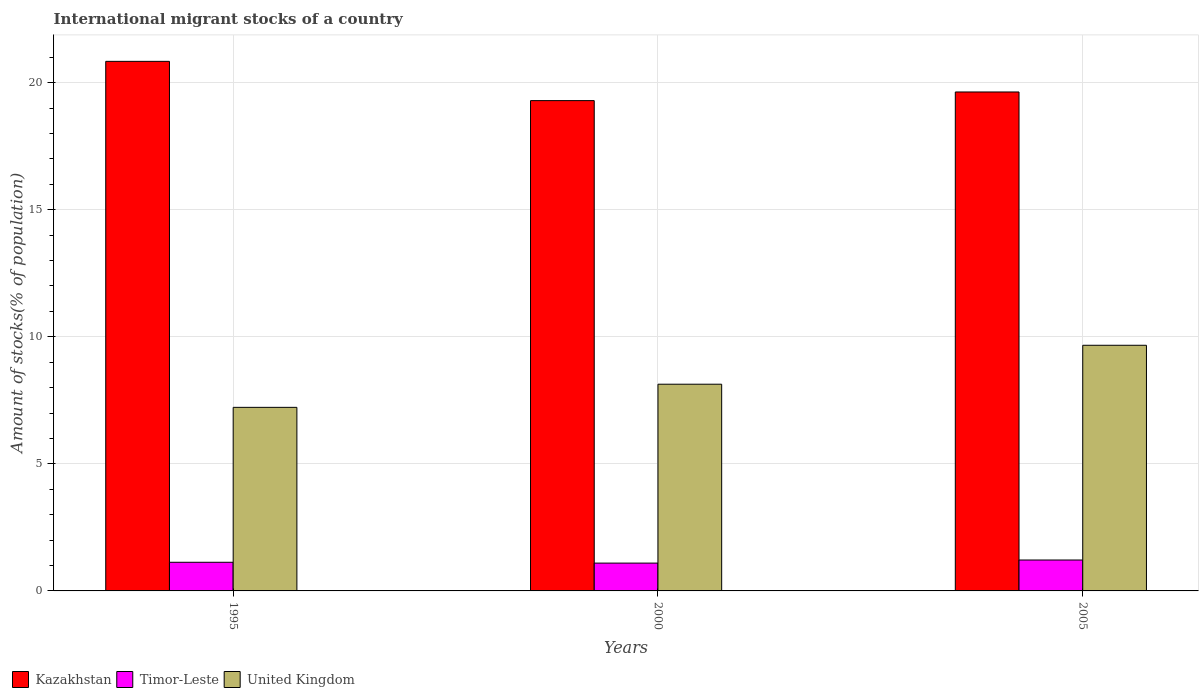How many groups of bars are there?
Ensure brevity in your answer.  3. Are the number of bars on each tick of the X-axis equal?
Your response must be concise. Yes. How many bars are there on the 3rd tick from the left?
Make the answer very short. 3. How many bars are there on the 1st tick from the right?
Keep it short and to the point. 3. What is the amount of stocks in in Timor-Leste in 2005?
Keep it short and to the point. 1.22. Across all years, what is the maximum amount of stocks in in Timor-Leste?
Give a very brief answer. 1.22. Across all years, what is the minimum amount of stocks in in Timor-Leste?
Provide a short and direct response. 1.09. In which year was the amount of stocks in in Timor-Leste maximum?
Give a very brief answer. 2005. In which year was the amount of stocks in in Timor-Leste minimum?
Ensure brevity in your answer.  2000. What is the total amount of stocks in in Timor-Leste in the graph?
Keep it short and to the point. 3.44. What is the difference between the amount of stocks in in Timor-Leste in 1995 and that in 2000?
Make the answer very short. 0.03. What is the difference between the amount of stocks in in Kazakhstan in 2000 and the amount of stocks in in Timor-Leste in 1995?
Offer a very short reply. 18.16. What is the average amount of stocks in in United Kingdom per year?
Provide a succinct answer. 8.34. In the year 1995, what is the difference between the amount of stocks in in Kazakhstan and amount of stocks in in Timor-Leste?
Keep it short and to the point. 19.71. What is the ratio of the amount of stocks in in Timor-Leste in 1995 to that in 2005?
Keep it short and to the point. 0.93. Is the amount of stocks in in Timor-Leste in 2000 less than that in 2005?
Offer a terse response. Yes. Is the difference between the amount of stocks in in Kazakhstan in 2000 and 2005 greater than the difference between the amount of stocks in in Timor-Leste in 2000 and 2005?
Ensure brevity in your answer.  No. What is the difference between the highest and the second highest amount of stocks in in Timor-Leste?
Keep it short and to the point. 0.09. What is the difference between the highest and the lowest amount of stocks in in Kazakhstan?
Provide a succinct answer. 1.54. What does the 3rd bar from the left in 2000 represents?
Make the answer very short. United Kingdom. What does the 2nd bar from the right in 1995 represents?
Offer a terse response. Timor-Leste. How many bars are there?
Provide a short and direct response. 9. Are all the bars in the graph horizontal?
Provide a succinct answer. No. How many years are there in the graph?
Offer a very short reply. 3. Does the graph contain grids?
Provide a succinct answer. Yes. Where does the legend appear in the graph?
Provide a short and direct response. Bottom left. How many legend labels are there?
Provide a succinct answer. 3. What is the title of the graph?
Give a very brief answer. International migrant stocks of a country. Does "Slovak Republic" appear as one of the legend labels in the graph?
Keep it short and to the point. No. What is the label or title of the X-axis?
Offer a terse response. Years. What is the label or title of the Y-axis?
Give a very brief answer. Amount of stocks(% of population). What is the Amount of stocks(% of population) of Kazakhstan in 1995?
Ensure brevity in your answer.  20.84. What is the Amount of stocks(% of population) of Timor-Leste in 1995?
Make the answer very short. 1.13. What is the Amount of stocks(% of population) of United Kingdom in 1995?
Provide a succinct answer. 7.22. What is the Amount of stocks(% of population) in Kazakhstan in 2000?
Keep it short and to the point. 19.29. What is the Amount of stocks(% of population) of Timor-Leste in 2000?
Provide a succinct answer. 1.09. What is the Amount of stocks(% of population) of United Kingdom in 2000?
Keep it short and to the point. 8.13. What is the Amount of stocks(% of population) of Kazakhstan in 2005?
Ensure brevity in your answer.  19.63. What is the Amount of stocks(% of population) of Timor-Leste in 2005?
Your response must be concise. 1.22. What is the Amount of stocks(% of population) in United Kingdom in 2005?
Your response must be concise. 9.66. Across all years, what is the maximum Amount of stocks(% of population) in Kazakhstan?
Your answer should be compact. 20.84. Across all years, what is the maximum Amount of stocks(% of population) of Timor-Leste?
Give a very brief answer. 1.22. Across all years, what is the maximum Amount of stocks(% of population) of United Kingdom?
Provide a succinct answer. 9.66. Across all years, what is the minimum Amount of stocks(% of population) in Kazakhstan?
Provide a short and direct response. 19.29. Across all years, what is the minimum Amount of stocks(% of population) of Timor-Leste?
Ensure brevity in your answer.  1.09. Across all years, what is the minimum Amount of stocks(% of population) of United Kingdom?
Offer a very short reply. 7.22. What is the total Amount of stocks(% of population) in Kazakhstan in the graph?
Your answer should be very brief. 59.76. What is the total Amount of stocks(% of population) in Timor-Leste in the graph?
Your answer should be compact. 3.44. What is the total Amount of stocks(% of population) in United Kingdom in the graph?
Make the answer very short. 25.02. What is the difference between the Amount of stocks(% of population) of Kazakhstan in 1995 and that in 2000?
Ensure brevity in your answer.  1.54. What is the difference between the Amount of stocks(% of population) in Timor-Leste in 1995 and that in 2000?
Your answer should be compact. 0.03. What is the difference between the Amount of stocks(% of population) of United Kingdom in 1995 and that in 2000?
Offer a very short reply. -0.91. What is the difference between the Amount of stocks(% of population) of Kazakhstan in 1995 and that in 2005?
Your response must be concise. 1.21. What is the difference between the Amount of stocks(% of population) in Timor-Leste in 1995 and that in 2005?
Provide a succinct answer. -0.09. What is the difference between the Amount of stocks(% of population) of United Kingdom in 1995 and that in 2005?
Ensure brevity in your answer.  -2.44. What is the difference between the Amount of stocks(% of population) in Kazakhstan in 2000 and that in 2005?
Your answer should be compact. -0.34. What is the difference between the Amount of stocks(% of population) in Timor-Leste in 2000 and that in 2005?
Give a very brief answer. -0.12. What is the difference between the Amount of stocks(% of population) in United Kingdom in 2000 and that in 2005?
Your answer should be very brief. -1.53. What is the difference between the Amount of stocks(% of population) in Kazakhstan in 1995 and the Amount of stocks(% of population) in Timor-Leste in 2000?
Your response must be concise. 19.74. What is the difference between the Amount of stocks(% of population) in Kazakhstan in 1995 and the Amount of stocks(% of population) in United Kingdom in 2000?
Provide a short and direct response. 12.7. What is the difference between the Amount of stocks(% of population) of Timor-Leste in 1995 and the Amount of stocks(% of population) of United Kingdom in 2000?
Keep it short and to the point. -7.01. What is the difference between the Amount of stocks(% of population) in Kazakhstan in 1995 and the Amount of stocks(% of population) in Timor-Leste in 2005?
Ensure brevity in your answer.  19.62. What is the difference between the Amount of stocks(% of population) in Kazakhstan in 1995 and the Amount of stocks(% of population) in United Kingdom in 2005?
Provide a short and direct response. 11.17. What is the difference between the Amount of stocks(% of population) of Timor-Leste in 1995 and the Amount of stocks(% of population) of United Kingdom in 2005?
Provide a succinct answer. -8.54. What is the difference between the Amount of stocks(% of population) of Kazakhstan in 2000 and the Amount of stocks(% of population) of Timor-Leste in 2005?
Provide a short and direct response. 18.08. What is the difference between the Amount of stocks(% of population) of Kazakhstan in 2000 and the Amount of stocks(% of population) of United Kingdom in 2005?
Your answer should be very brief. 9.63. What is the difference between the Amount of stocks(% of population) of Timor-Leste in 2000 and the Amount of stocks(% of population) of United Kingdom in 2005?
Keep it short and to the point. -8.57. What is the average Amount of stocks(% of population) in Kazakhstan per year?
Your response must be concise. 19.92. What is the average Amount of stocks(% of population) of Timor-Leste per year?
Offer a very short reply. 1.15. What is the average Amount of stocks(% of population) in United Kingdom per year?
Keep it short and to the point. 8.34. In the year 1995, what is the difference between the Amount of stocks(% of population) in Kazakhstan and Amount of stocks(% of population) in Timor-Leste?
Provide a succinct answer. 19.71. In the year 1995, what is the difference between the Amount of stocks(% of population) of Kazakhstan and Amount of stocks(% of population) of United Kingdom?
Keep it short and to the point. 13.61. In the year 1995, what is the difference between the Amount of stocks(% of population) of Timor-Leste and Amount of stocks(% of population) of United Kingdom?
Keep it short and to the point. -6.1. In the year 2000, what is the difference between the Amount of stocks(% of population) in Kazakhstan and Amount of stocks(% of population) in Timor-Leste?
Keep it short and to the point. 18.2. In the year 2000, what is the difference between the Amount of stocks(% of population) in Kazakhstan and Amount of stocks(% of population) in United Kingdom?
Offer a terse response. 11.16. In the year 2000, what is the difference between the Amount of stocks(% of population) in Timor-Leste and Amount of stocks(% of population) in United Kingdom?
Provide a short and direct response. -7.04. In the year 2005, what is the difference between the Amount of stocks(% of population) of Kazakhstan and Amount of stocks(% of population) of Timor-Leste?
Provide a succinct answer. 18.42. In the year 2005, what is the difference between the Amount of stocks(% of population) in Kazakhstan and Amount of stocks(% of population) in United Kingdom?
Your answer should be very brief. 9.97. In the year 2005, what is the difference between the Amount of stocks(% of population) in Timor-Leste and Amount of stocks(% of population) in United Kingdom?
Keep it short and to the point. -8.45. What is the ratio of the Amount of stocks(% of population) in Kazakhstan in 1995 to that in 2000?
Keep it short and to the point. 1.08. What is the ratio of the Amount of stocks(% of population) of Timor-Leste in 1995 to that in 2000?
Provide a succinct answer. 1.03. What is the ratio of the Amount of stocks(% of population) of United Kingdom in 1995 to that in 2000?
Your answer should be very brief. 0.89. What is the ratio of the Amount of stocks(% of population) in Kazakhstan in 1995 to that in 2005?
Your answer should be compact. 1.06. What is the ratio of the Amount of stocks(% of population) of Timor-Leste in 1995 to that in 2005?
Your response must be concise. 0.93. What is the ratio of the Amount of stocks(% of population) in United Kingdom in 1995 to that in 2005?
Keep it short and to the point. 0.75. What is the ratio of the Amount of stocks(% of population) of Kazakhstan in 2000 to that in 2005?
Your response must be concise. 0.98. What is the ratio of the Amount of stocks(% of population) in Timor-Leste in 2000 to that in 2005?
Give a very brief answer. 0.9. What is the ratio of the Amount of stocks(% of population) of United Kingdom in 2000 to that in 2005?
Make the answer very short. 0.84. What is the difference between the highest and the second highest Amount of stocks(% of population) of Kazakhstan?
Keep it short and to the point. 1.21. What is the difference between the highest and the second highest Amount of stocks(% of population) of Timor-Leste?
Your answer should be compact. 0.09. What is the difference between the highest and the second highest Amount of stocks(% of population) in United Kingdom?
Keep it short and to the point. 1.53. What is the difference between the highest and the lowest Amount of stocks(% of population) in Kazakhstan?
Your response must be concise. 1.54. What is the difference between the highest and the lowest Amount of stocks(% of population) of Timor-Leste?
Provide a succinct answer. 0.12. What is the difference between the highest and the lowest Amount of stocks(% of population) of United Kingdom?
Give a very brief answer. 2.44. 